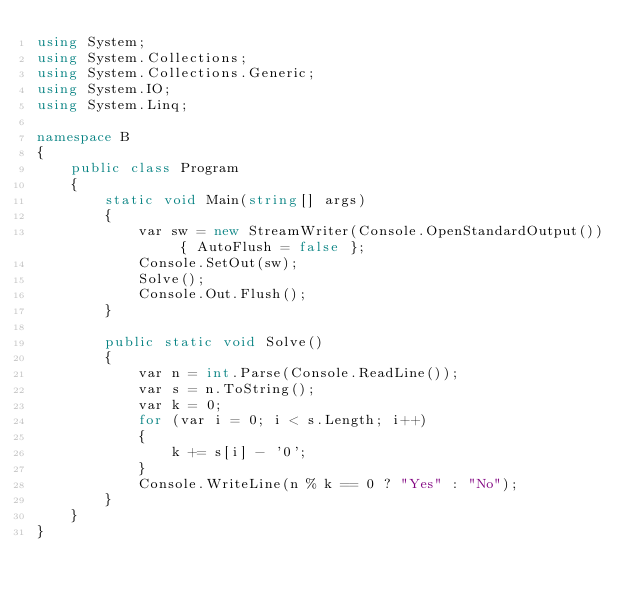Convert code to text. <code><loc_0><loc_0><loc_500><loc_500><_C#_>using System;
using System.Collections;
using System.Collections.Generic;
using System.IO;
using System.Linq;

namespace B
{
    public class Program
    {
        static void Main(string[] args)
        {
            var sw = new StreamWriter(Console.OpenStandardOutput()) { AutoFlush = false };
            Console.SetOut(sw);
            Solve();
            Console.Out.Flush();
        }

        public static void Solve()
        {
            var n = int.Parse(Console.ReadLine());
            var s = n.ToString();
            var k = 0;
            for (var i = 0; i < s.Length; i++)
            {
                k += s[i] - '0';
            }
            Console.WriteLine(n % k == 0 ? "Yes" : "No");
        }
    }
}
</code> 